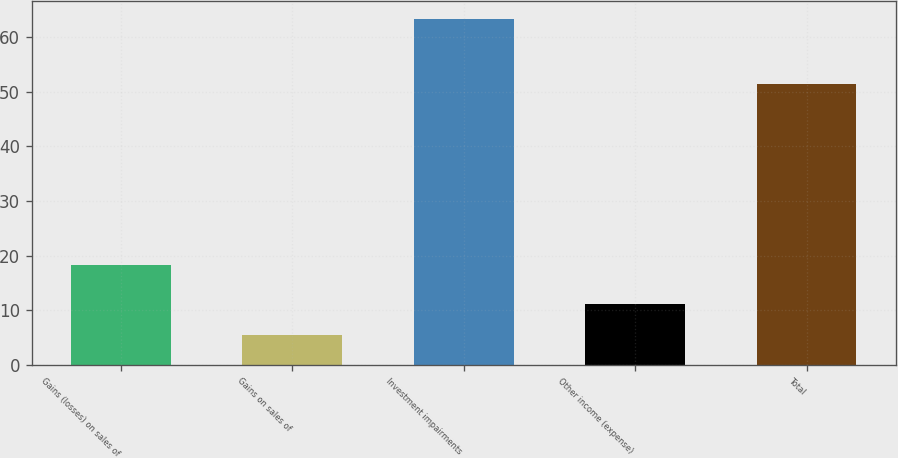<chart> <loc_0><loc_0><loc_500><loc_500><bar_chart><fcel>Gains (losses) on sales of<fcel>Gains on sales of<fcel>Investment impairments<fcel>Other income (expense)<fcel>Total<nl><fcel>18.2<fcel>5.4<fcel>63.4<fcel>11.2<fcel>51.4<nl></chart> 